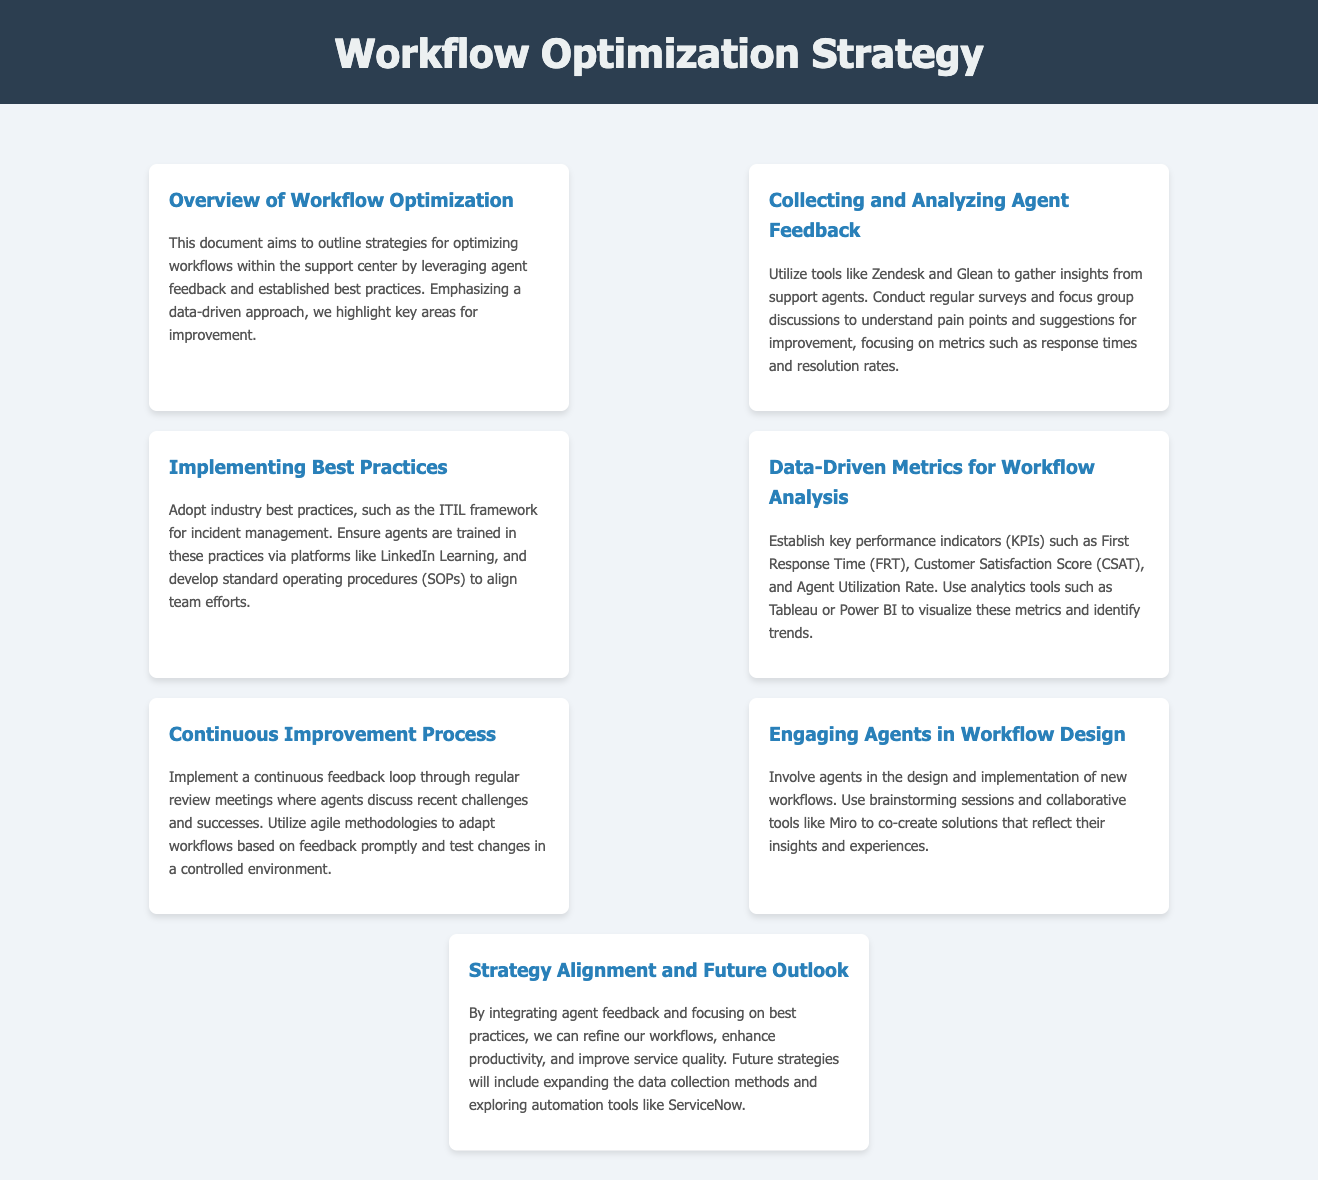What is the primary aim of the document? The document aims to outline strategies for optimizing workflows within the support center by leveraging agent feedback and established best practices.
Answer: Optimize workflows What tools are suggested for collecting agent feedback? The document mentions using tools like Zendesk and Glean for gathering insights.
Answer: Zendesk and Glean Which framework is recommended for incident management? The document suggests adopting the ITIL framework for incident management as a best practice.
Answer: ITIL What key performance indicator is related to response time? The document refers to First Response Time (FRT) as a KPI related to response time.
Answer: First Response Time (FRT) What methodology is suggested for implementing changes based on feedback? The continuous improvement process recommends utilizing agile methodologies to adapt workflows based on feedback.
Answer: Agile methodologies How can agents engage in the design of workflows? The document states that agents can engage through brainstorming sessions and collaborative tools like Miro.
Answer: Brainstorming sessions and Miro What is a future strategy mentioned in the document? The document mentions exploring automation tools like ServiceNow as a future strategy.
Answer: ServiceNow What is the focus of the continuous feedback loop? The continuous feedback loop focuses on regular review meetings where agents discuss recent challenges and successes.
Answer: Regular review meetings What metric is mentioned for assessing customer satisfaction? Customer Satisfaction Score (CSAT) is mentioned as a metric for assessing satisfaction.
Answer: Customer Satisfaction Score (CSAT) 